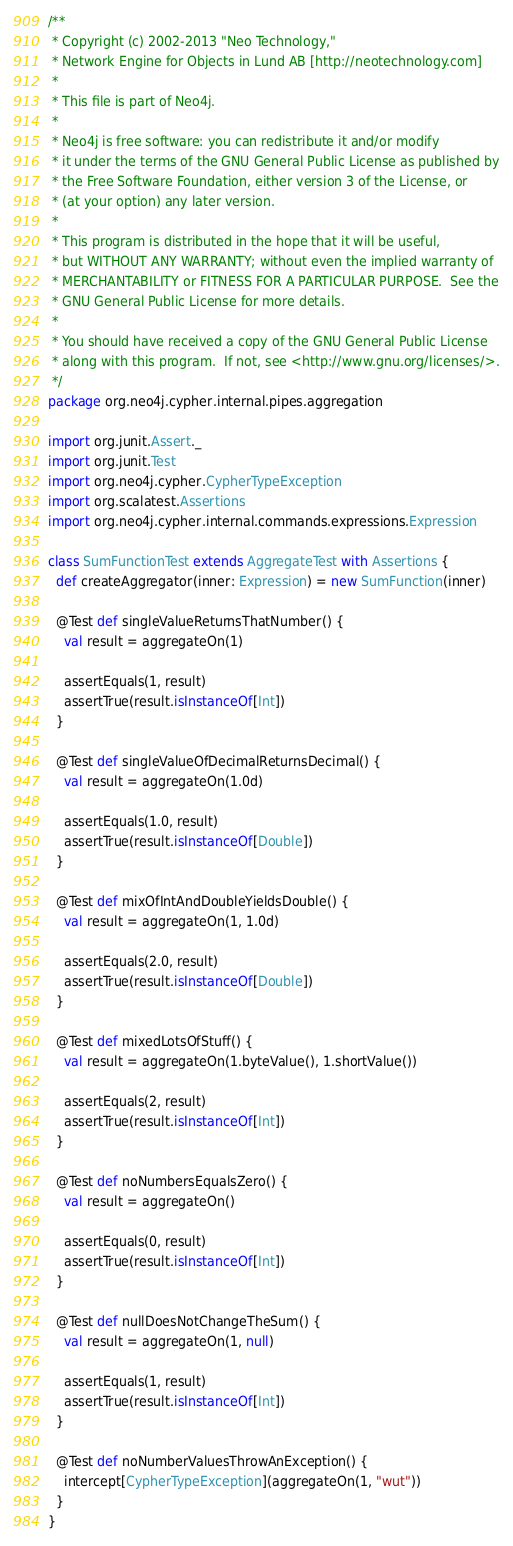Convert code to text. <code><loc_0><loc_0><loc_500><loc_500><_Scala_>/**
 * Copyright (c) 2002-2013 "Neo Technology,"
 * Network Engine for Objects in Lund AB [http://neotechnology.com]
 *
 * This file is part of Neo4j.
 *
 * Neo4j is free software: you can redistribute it and/or modify
 * it under the terms of the GNU General Public License as published by
 * the Free Software Foundation, either version 3 of the License, or
 * (at your option) any later version.
 *
 * This program is distributed in the hope that it will be useful,
 * but WITHOUT ANY WARRANTY; without even the implied warranty of
 * MERCHANTABILITY or FITNESS FOR A PARTICULAR PURPOSE.  See the
 * GNU General Public License for more details.
 *
 * You should have received a copy of the GNU General Public License
 * along with this program.  If not, see <http://www.gnu.org/licenses/>.
 */
package org.neo4j.cypher.internal.pipes.aggregation

import org.junit.Assert._
import org.junit.Test
import org.neo4j.cypher.CypherTypeException
import org.scalatest.Assertions
import org.neo4j.cypher.internal.commands.expressions.Expression

class SumFunctionTest extends AggregateTest with Assertions {
  def createAggregator(inner: Expression) = new SumFunction(inner)

  @Test def singleValueReturnsThatNumber() {
    val result = aggregateOn(1)

    assertEquals(1, result)
    assertTrue(result.isInstanceOf[Int])
  }

  @Test def singleValueOfDecimalReturnsDecimal() {
    val result = aggregateOn(1.0d)

    assertEquals(1.0, result)
    assertTrue(result.isInstanceOf[Double])
  }

  @Test def mixOfIntAndDoubleYieldsDouble() {
    val result = aggregateOn(1, 1.0d)

    assertEquals(2.0, result)
    assertTrue(result.isInstanceOf[Double])
  }

  @Test def mixedLotsOfStuff() {
    val result = aggregateOn(1.byteValue(), 1.shortValue())

    assertEquals(2, result)
    assertTrue(result.isInstanceOf[Int])
  }

  @Test def noNumbersEqualsZero() {
    val result = aggregateOn()

    assertEquals(0, result)
    assertTrue(result.isInstanceOf[Int])
  }

  @Test def nullDoesNotChangeTheSum() {
    val result = aggregateOn(1, null)

    assertEquals(1, result)
    assertTrue(result.isInstanceOf[Int])
  }

  @Test def noNumberValuesThrowAnException() {
    intercept[CypherTypeException](aggregateOn(1, "wut"))
  }
}
</code> 